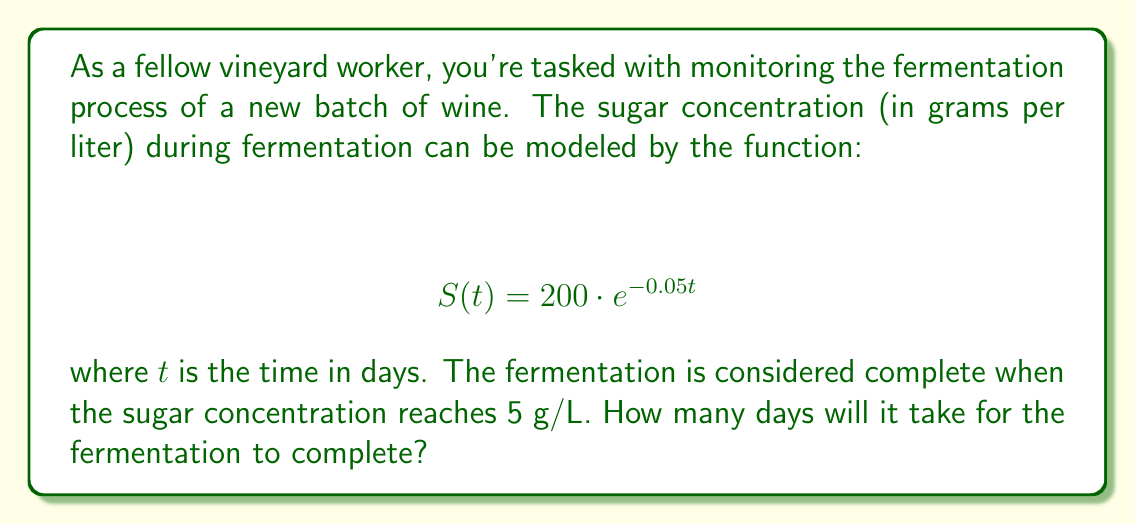Show me your answer to this math problem. To solve this problem, we need to use logarithms to isolate the variable $t$. Let's approach this step-by-step:

1) We want to find $t$ when $S(t) = 5$ g/L. So, we set up the equation:

   $$ 5 = 200 \cdot e^{-0.05t} $$

2) Divide both sides by 200:

   $$ \frac{5}{200} = e^{-0.05t} $$

3) Take the natural logarithm of both sides. Remember, $\ln(e^x) = x$:

   $$ \ln(\frac{5}{200}) = \ln(e^{-0.05t}) = -0.05t $$

4) Simplify the left side:

   $$ \ln(0.025) = -0.05t $$

5) Divide both sides by -0.05:

   $$ \frac{\ln(0.025)}{-0.05} = t $$

6) Calculate the result:

   $$ t \approx 73.78 $$

Therefore, it will take approximately 73.78 days for the fermentation to complete.
Answer: 73.78 days 